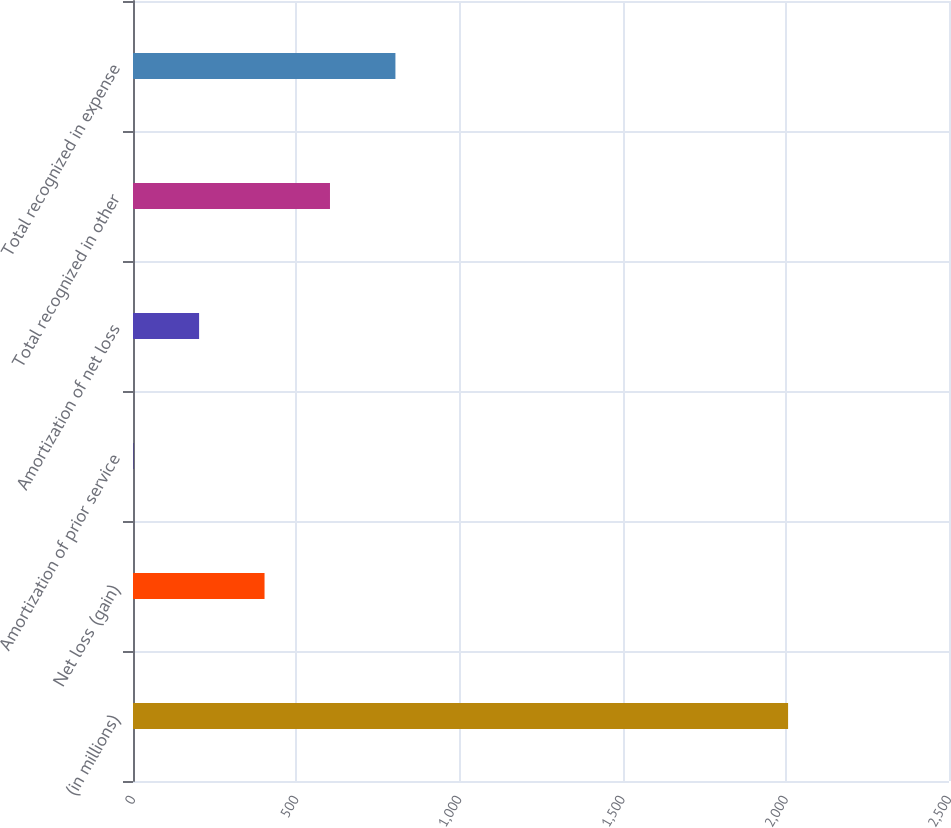<chart> <loc_0><loc_0><loc_500><loc_500><bar_chart><fcel>(in millions)<fcel>Net loss (gain)<fcel>Amortization of prior service<fcel>Amortization of net loss<fcel>Total recognized in other<fcel>Total recognized in expense<nl><fcel>2007<fcel>403<fcel>2<fcel>202.5<fcel>603.5<fcel>804<nl></chart> 